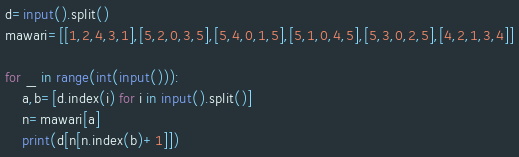Convert code to text. <code><loc_0><loc_0><loc_500><loc_500><_Python_>d=input().split()
mawari=[[1,2,4,3,1],[5,2,0,3,5],[5,4,0,1,5],[5,1,0,4,5],[5,3,0,2,5],[4,2,1,3,4]]

for _ in range(int(input())):
    a,b=[d.index(i) for i in input().split()]
    n=mawari[a]
    print(d[n[n.index(b)+1]])
</code> 